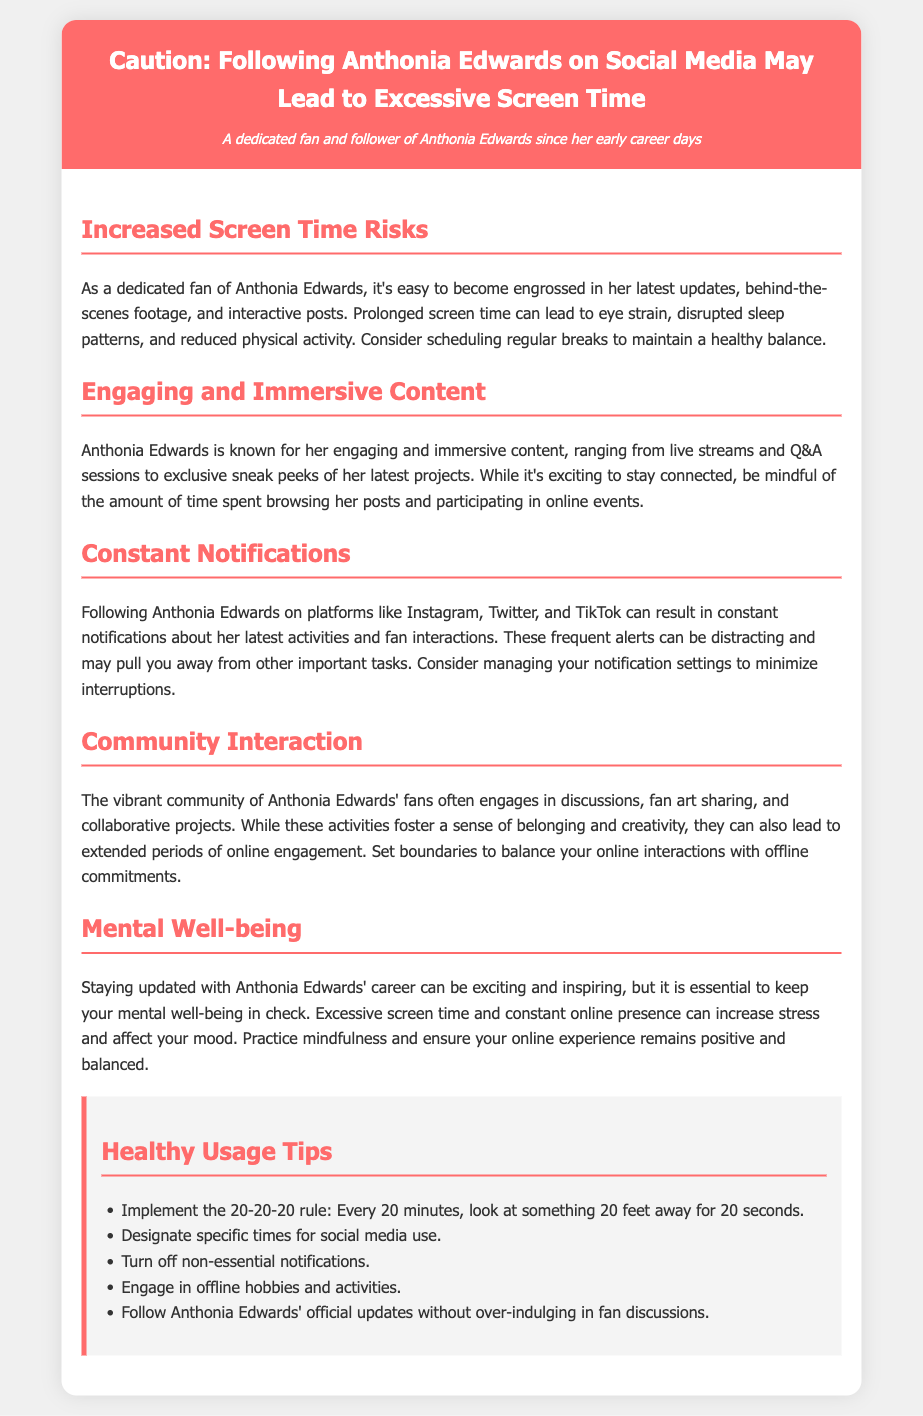What is the title of the document? The title of the document is given in the header, indicating its purpose.
Answer: Caution: Following Anthonia Edwards on Social Media May Lead to Excessive Screen Time What is one risk associated with increased screen time? The document lists various risks, and one specific risk mentioned is related to health.
Answer: Eye strain What is the 20-20-20 rule? The 20-20-20 rule is presented in the Healthy Usage Tips section, which promotes eye health during screen use.
Answer: Look at something 20 feet away for 20 seconds What does constant notifications from social media cause? The document explains the effects of notifications, and one specific consequence is noted.
Answer: Distractions How can one balance online interactions with offline commitments? The document provides content aimed at setting boundaries to manage online engagement.
Answer: Set boundaries What is a suggested solution to minimize interruptions from social media? The document gives practical strategies, and managing notifications is mentioned.
Answer: Turn off non-essential notifications 